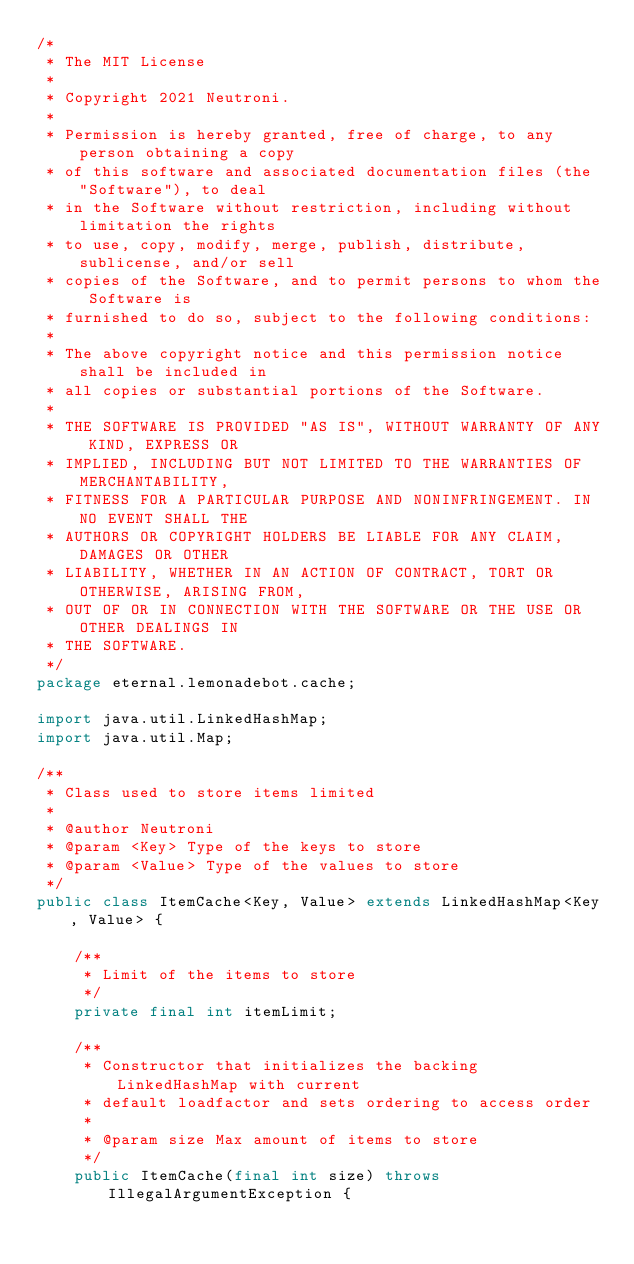Convert code to text. <code><loc_0><loc_0><loc_500><loc_500><_Java_>/*
 * The MIT License
 *
 * Copyright 2021 Neutroni.
 *
 * Permission is hereby granted, free of charge, to any person obtaining a copy
 * of this software and associated documentation files (the "Software"), to deal
 * in the Software without restriction, including without limitation the rights
 * to use, copy, modify, merge, publish, distribute, sublicense, and/or sell
 * copies of the Software, and to permit persons to whom the Software is
 * furnished to do so, subject to the following conditions:
 *
 * The above copyright notice and this permission notice shall be included in
 * all copies or substantial portions of the Software.
 *
 * THE SOFTWARE IS PROVIDED "AS IS", WITHOUT WARRANTY OF ANY KIND, EXPRESS OR
 * IMPLIED, INCLUDING BUT NOT LIMITED TO THE WARRANTIES OF MERCHANTABILITY,
 * FITNESS FOR A PARTICULAR PURPOSE AND NONINFRINGEMENT. IN NO EVENT SHALL THE
 * AUTHORS OR COPYRIGHT HOLDERS BE LIABLE FOR ANY CLAIM, DAMAGES OR OTHER
 * LIABILITY, WHETHER IN AN ACTION OF CONTRACT, TORT OR OTHERWISE, ARISING FROM,
 * OUT OF OR IN CONNECTION WITH THE SOFTWARE OR THE USE OR OTHER DEALINGS IN
 * THE SOFTWARE.
 */
package eternal.lemonadebot.cache;

import java.util.LinkedHashMap;
import java.util.Map;

/**
 * Class used to store items limited
 *
 * @author Neutroni
 * @param <Key> Type of the keys to store
 * @param <Value> Type of the values to store
 */
public class ItemCache<Key, Value> extends LinkedHashMap<Key, Value> {

    /**
     * Limit of the items to store
     */
    private final int itemLimit;

    /**
     * Constructor that initializes the backing LinkedHashMap with current
     * default loadfactor and sets ordering to access order
     *
     * @param size Max amount of items to store
     */
    public ItemCache(final int size) throws IllegalArgumentException {</code> 